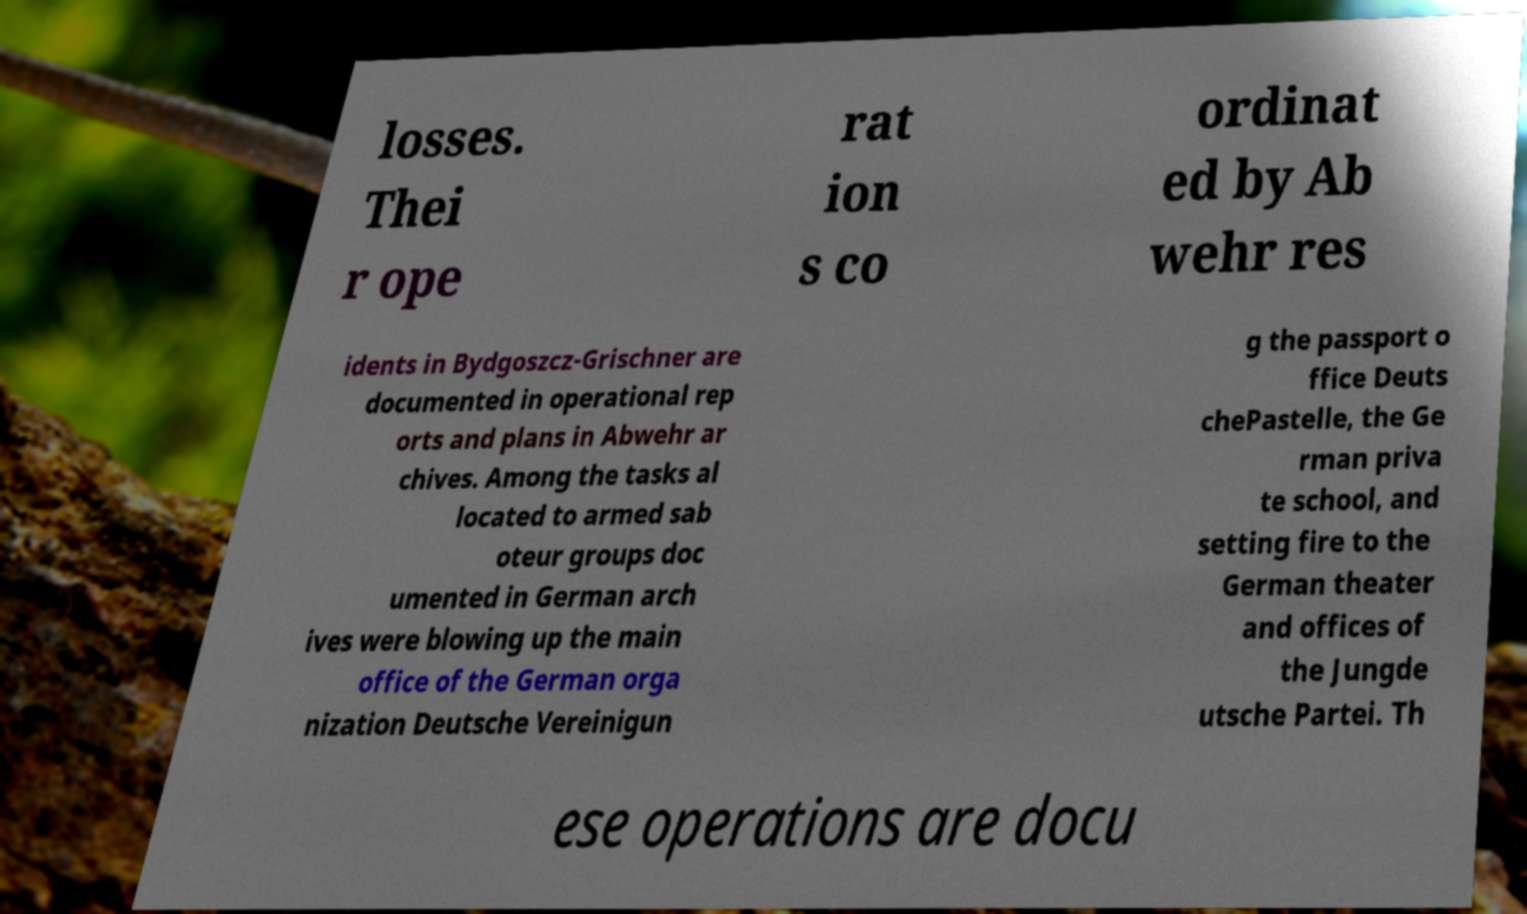Please identify and transcribe the text found in this image. losses. Thei r ope rat ion s co ordinat ed by Ab wehr res idents in Bydgoszcz-Grischner are documented in operational rep orts and plans in Abwehr ar chives. Among the tasks al located to armed sab oteur groups doc umented in German arch ives were blowing up the main office of the German orga nization Deutsche Vereinigun g the passport o ffice Deuts chePastelle, the Ge rman priva te school, and setting fire to the German theater and offices of the Jungde utsche Partei. Th ese operations are docu 